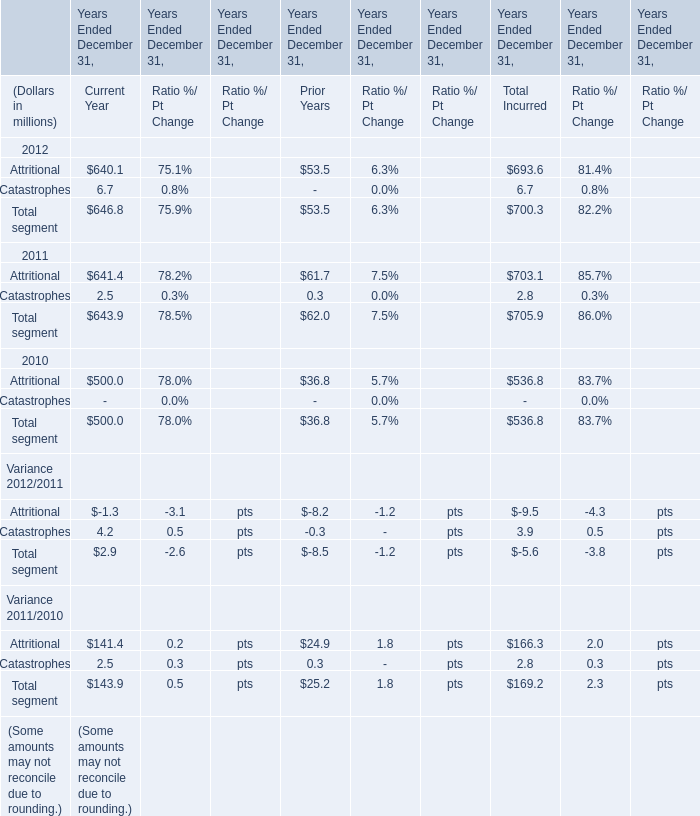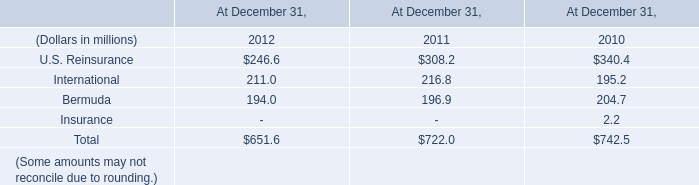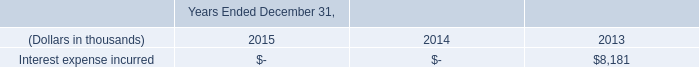Which year is Attritional the most in Current Year? 
Answer: 2011. 